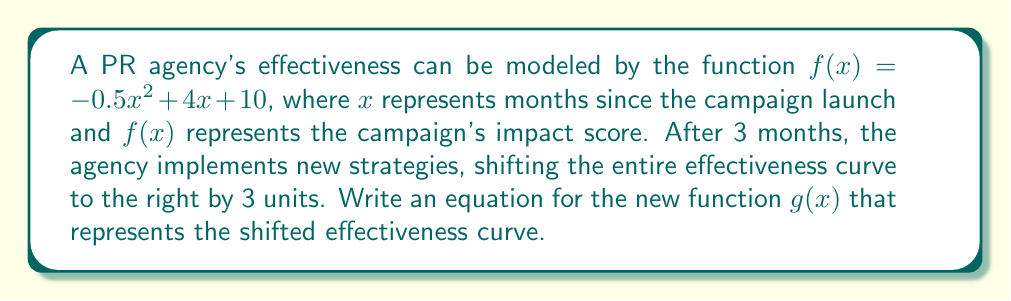Show me your answer to this math problem. To solve this problem, we need to understand how to shift a function horizontally:

1. The original function is $f(x) = -0.5x^2 + 4x + 10$.

2. To shift a function to the right by $h$ units, we replace every $x$ in the original function with $(x - h)$.

3. In this case, we're shifting 3 units to the right, so $h = 3$.

4. Let's replace every $x$ in $f(x)$ with $(x - 3)$:

   $g(x) = -0.5(x - 3)^2 + 4(x - 3) + 10$

5. Now, let's expand this:
   
   $g(x) = -0.5(x^2 - 6x + 9) + 4x - 12 + 10$
   
   $g(x) = -0.5x^2 + 3x - 4.5 + 4x - 12 + 10$
   
   $g(x) = -0.5x^2 + 7x - 6.5$

6. This final form, $g(x) = -0.5x^2 + 7x - 6.5$, represents the shifted function.

This shift illustrates how the PR campaign's effectiveness curve has moved due to the new strategies implemented after 3 months. The shape of the curve remains the same, but it's now positioned 3 units to the right on the x-axis, reflecting the delayed peak effectiveness due to the new strategies.
Answer: $g(x) = -0.5x^2 + 7x - 6.5$ 